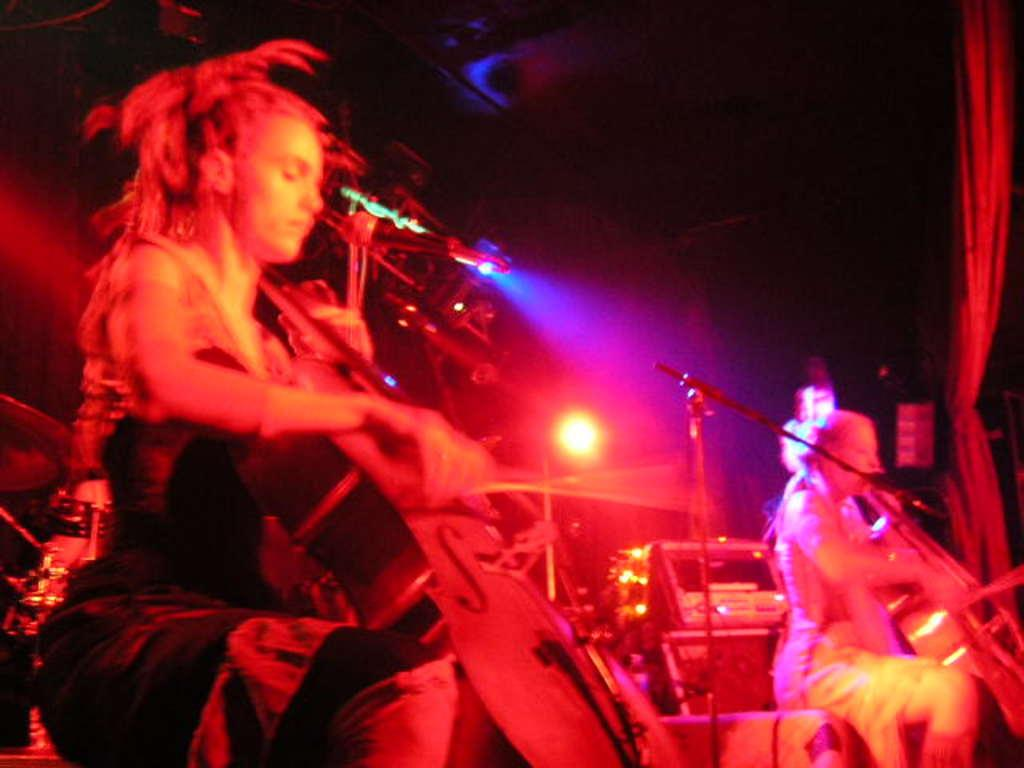What is happening in the image? There is a group of people in the image, and they are playing music. Can you describe the activity the people are engaged in? The people are playing music, which suggests they might be musicians or participating in a musical event. What type of kitty can be seen ploughing the field in the image? There is no kitty or field present in the image; it features a group of people playing music. 